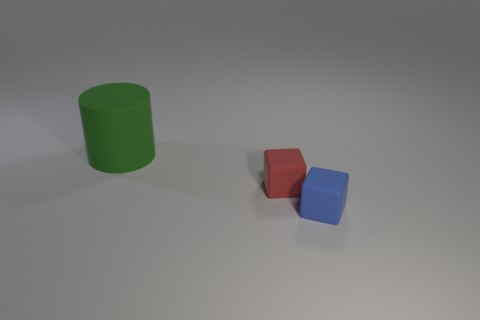Add 2 gray cylinders. How many objects exist? 5 Add 3 small matte cubes. How many small matte cubes are left? 5 Add 3 small cyan shiny objects. How many small cyan shiny objects exist? 3 Subtract 0 green spheres. How many objects are left? 3 Subtract all cylinders. How many objects are left? 2 Subtract all matte blocks. Subtract all big gray matte balls. How many objects are left? 1 